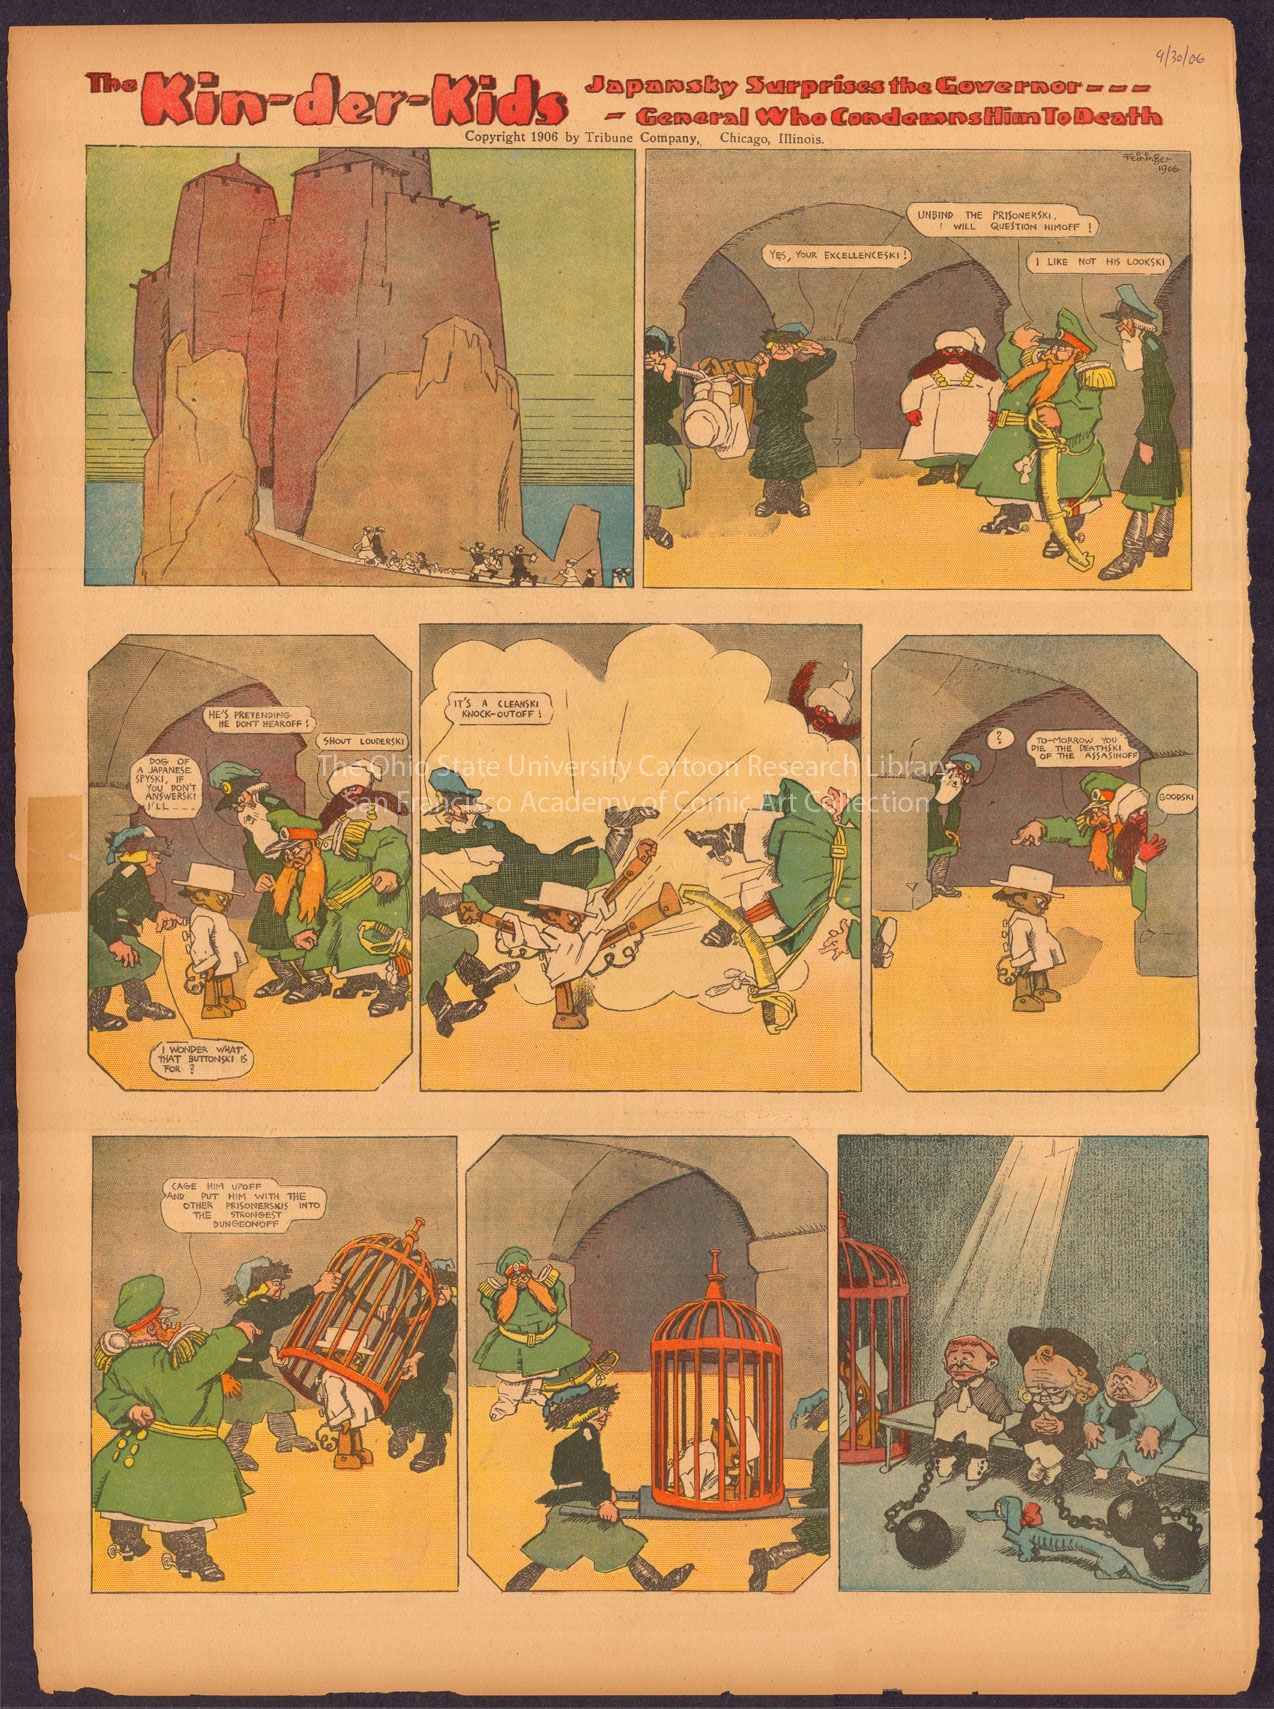Describe the following image.
 The image presents a comic strip titled "The Kin-der-Kids". The comic strip is divided into six panels, each depicting a different scene. The art style is reminiscent of early 20th century comics, characterized by bold lines and flat colors. The comic strip appears to be a humorous take on the adventures of a group of children, with each panel depicting the children in different situations. The colors used in the comic strip are mostly earthy tones, with occasional splashes of brighter colors. The title "The Kin-der-Kids" is visible in the comic strip, suggesting that the children depicted are the main characters of the story. The comic strip does not provide any clear indication of the art genre, but the style and content suggest that it may be a form of narrative art. The comic strip does not contain any text, making it difficult to determine the exact storyline or context of the scenes depicted. However, the images alone convey a sense of whimsy and adventure, characteristic of many children's comics from the early 20th century. The comic strip is a fascinating example of early comic art, offering a glimpse into the visual storytelling techniques of the time. 